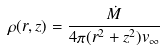<formula> <loc_0><loc_0><loc_500><loc_500>\rho ( r , z ) = \frac { \dot { M } } { 4 \pi ( r ^ { 2 } + z ^ { 2 } ) v _ { \infty } }</formula> 